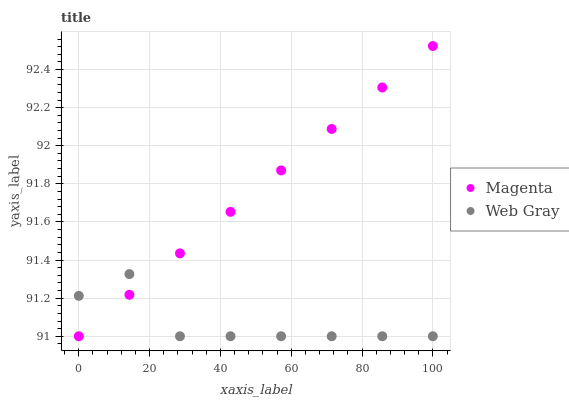Does Web Gray have the minimum area under the curve?
Answer yes or no. Yes. Does Magenta have the maximum area under the curve?
Answer yes or no. Yes. Does Web Gray have the maximum area under the curve?
Answer yes or no. No. Is Magenta the smoothest?
Answer yes or no. Yes. Is Web Gray the roughest?
Answer yes or no. Yes. Is Web Gray the smoothest?
Answer yes or no. No. Does Magenta have the lowest value?
Answer yes or no. Yes. Does Magenta have the highest value?
Answer yes or no. Yes. Does Web Gray have the highest value?
Answer yes or no. No. Does Web Gray intersect Magenta?
Answer yes or no. Yes. Is Web Gray less than Magenta?
Answer yes or no. No. Is Web Gray greater than Magenta?
Answer yes or no. No. 